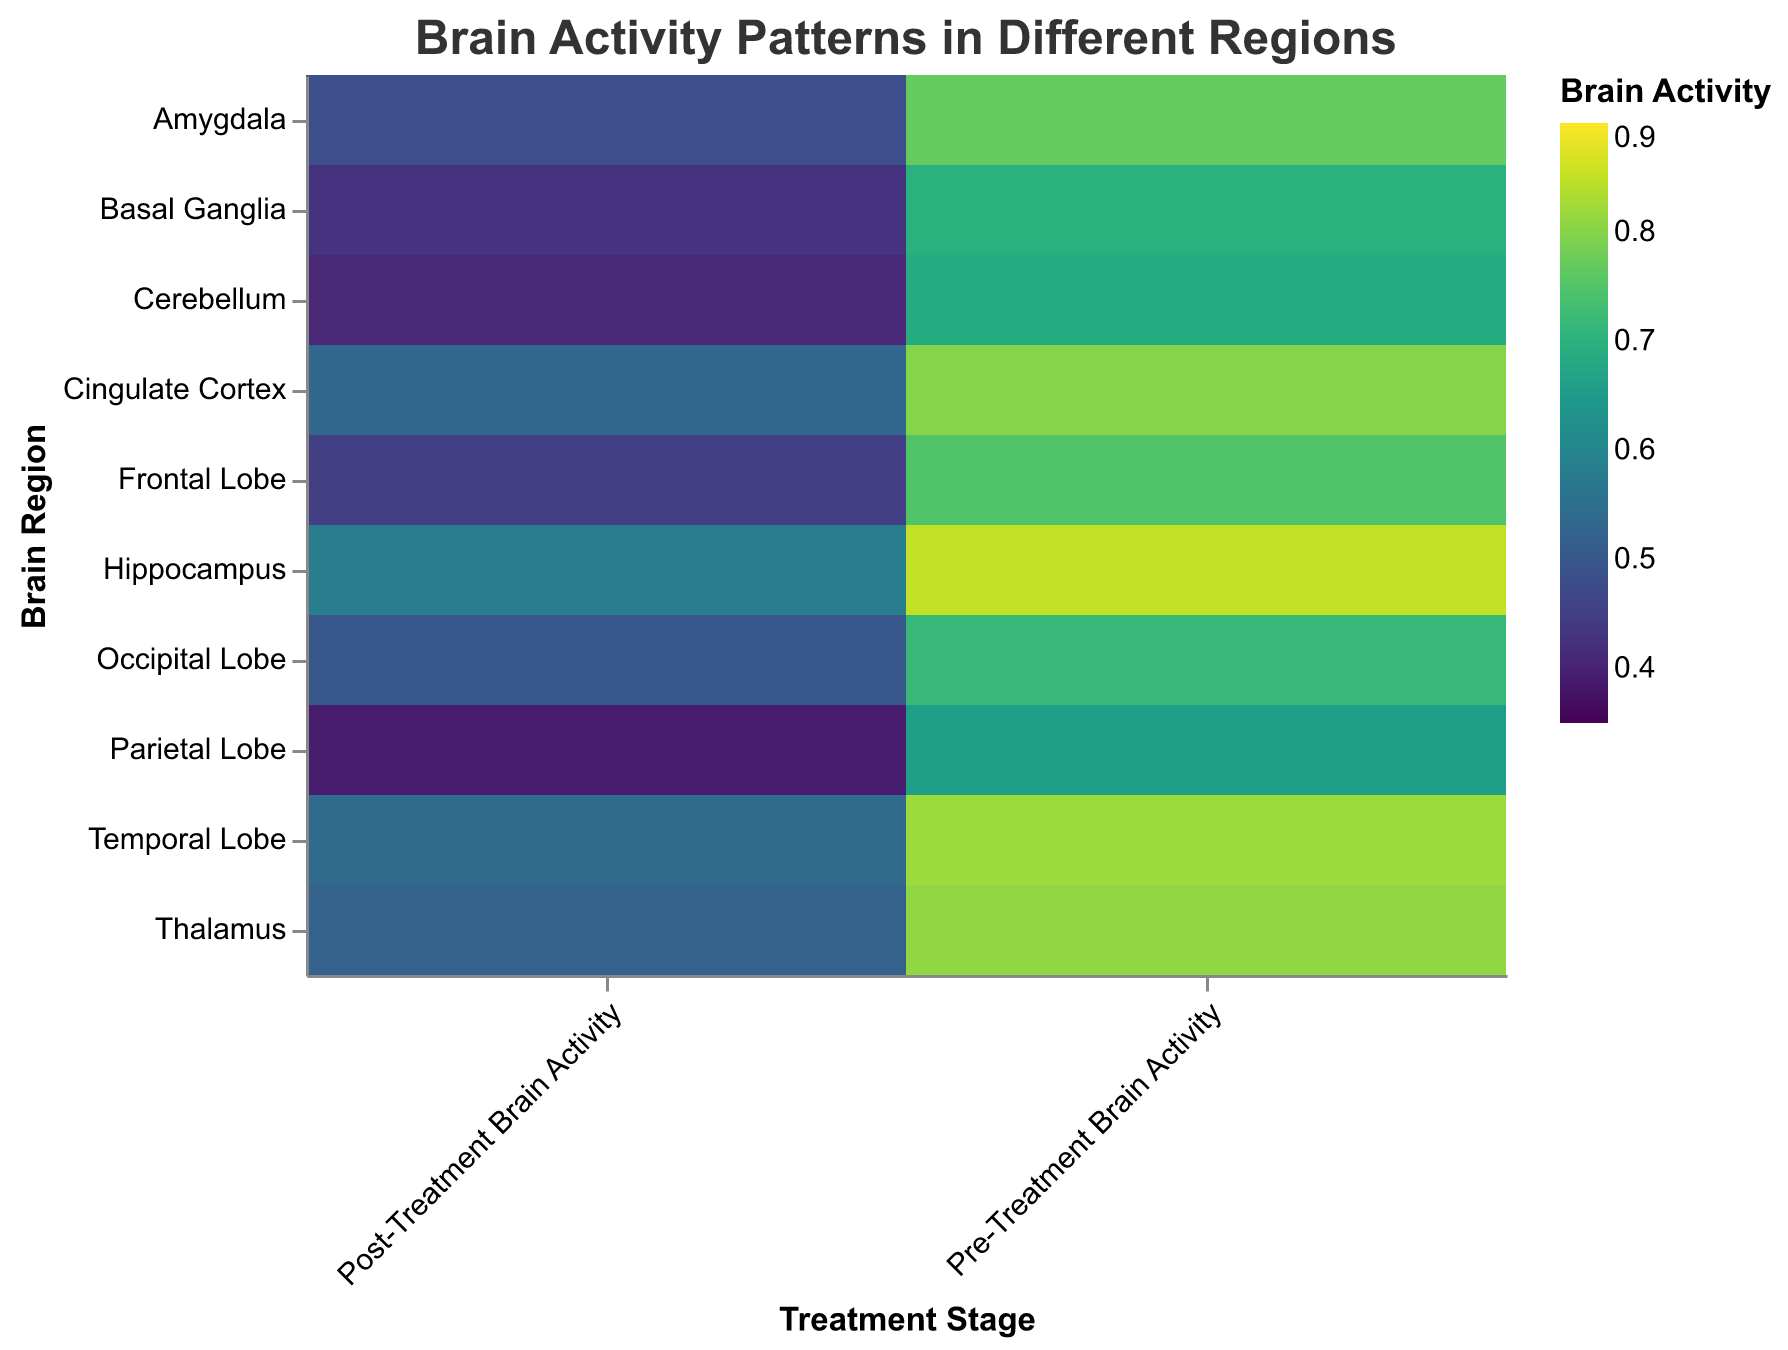What is the highest pre-treatment brain activity value shown on the heatmap? Look at the "Pre-Treatment Brain Activity" column in the heatmap and identify the highest value. The highest value is 0.85, found in the Hippocampus region.
Answer: 0.85 Which brain region shows the greatest decrease in brain activity after treatment? Compare the difference between pre-treatment and post-treatment brain activity values for each region. The greatest decrease is observed in the Hippocampus, with a difference of 0.85 - 0.58 = 0.27.
Answer: Hippocampus What does the color scale represent in the heatmap? The color scale represents brain activity levels, with different colors indicating various activity levels ranging from low to high according to the viridis color scheme.
Answer: Brain activity levels How does the frontal lobe's brain activity change after treatment? Locate the frontal lobe row in the heatmap and compare the pre-treatment and post-treatment brain activity values. Pre-treatment activity is 0.75, and post-treatment activity is 0.45, showing a decrease.
Answer: Decreases Which treatment stage shows higher overall brain activity across all regions, pre-treatment or post-treatment? Compare the overall colors for pre-treatment and post-treatment stages. Pre-treatment generally has higher activity (darker colors) compared to post-treatment (lighter colors).
Answer: Pre-treatment Which brain region has the lowest post-treatment brain activity? Identify the lightest color in the "Post-Treatment Brain Activity" column. The lowest value is 0.39 in the Parietal Lobe.
Answer: Parietal Lobe What pattern can be observed about brain activity changes due to treatment? Observe the color scale and activity values before and after treatment. All regions show a decrease in brain activity post-treatment, indicated by lighter colors shifting from the left to the right.
Answer: Decrease in brain activity How many data regions do not have post-treatment values below 0.5? Count the regions with post-treatment brain activity values of 0.5 or above. These regions are Temporal Lobe, Occipital Lobe, Cingulate Cortex, Hippocampus, Thalamus.
Answer: 5 regions Which brain region shows a similar pattern of activity change to the Cingulate Cortex? Compare the differences in brain activity from pre-treatment to post-treatment across other regions with Cingulate Cortex (0.80 to 0.53). Frontal Lobe and Amygdala show similar patterns with decreases in activity from around 0.75 - 0.8 to 0.45 - 0.48.
Answer: Frontal Lobe and Amygdala 